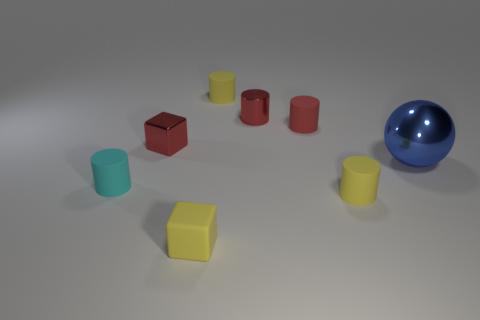Is there anything else that is the same size as the ball?
Ensure brevity in your answer.  No. There is a small red matte object; is its shape the same as the small yellow rubber object behind the sphere?
Make the answer very short. Yes. There is a yellow rubber thing that is behind the blue ball; what is its size?
Provide a short and direct response. Small. What material is the cyan thing?
Offer a very short reply. Rubber. There is a small metallic object that is to the right of the metal cube; is it the same shape as the cyan object?
Provide a short and direct response. Yes. There is a shiny object that is the same color as the metal block; what size is it?
Your answer should be compact. Small. Is there a green metallic cylinder of the same size as the metal cube?
Your answer should be compact. No. There is a block that is in front of the cylinder on the left side of the small yellow block; are there any small red rubber cylinders that are in front of it?
Your answer should be compact. No. Do the tiny metallic cube and the tiny metal object that is right of the yellow cube have the same color?
Provide a short and direct response. Yes. What is the material of the yellow cylinder in front of the small yellow thing behind the tiny matte cylinder in front of the cyan rubber cylinder?
Ensure brevity in your answer.  Rubber. 